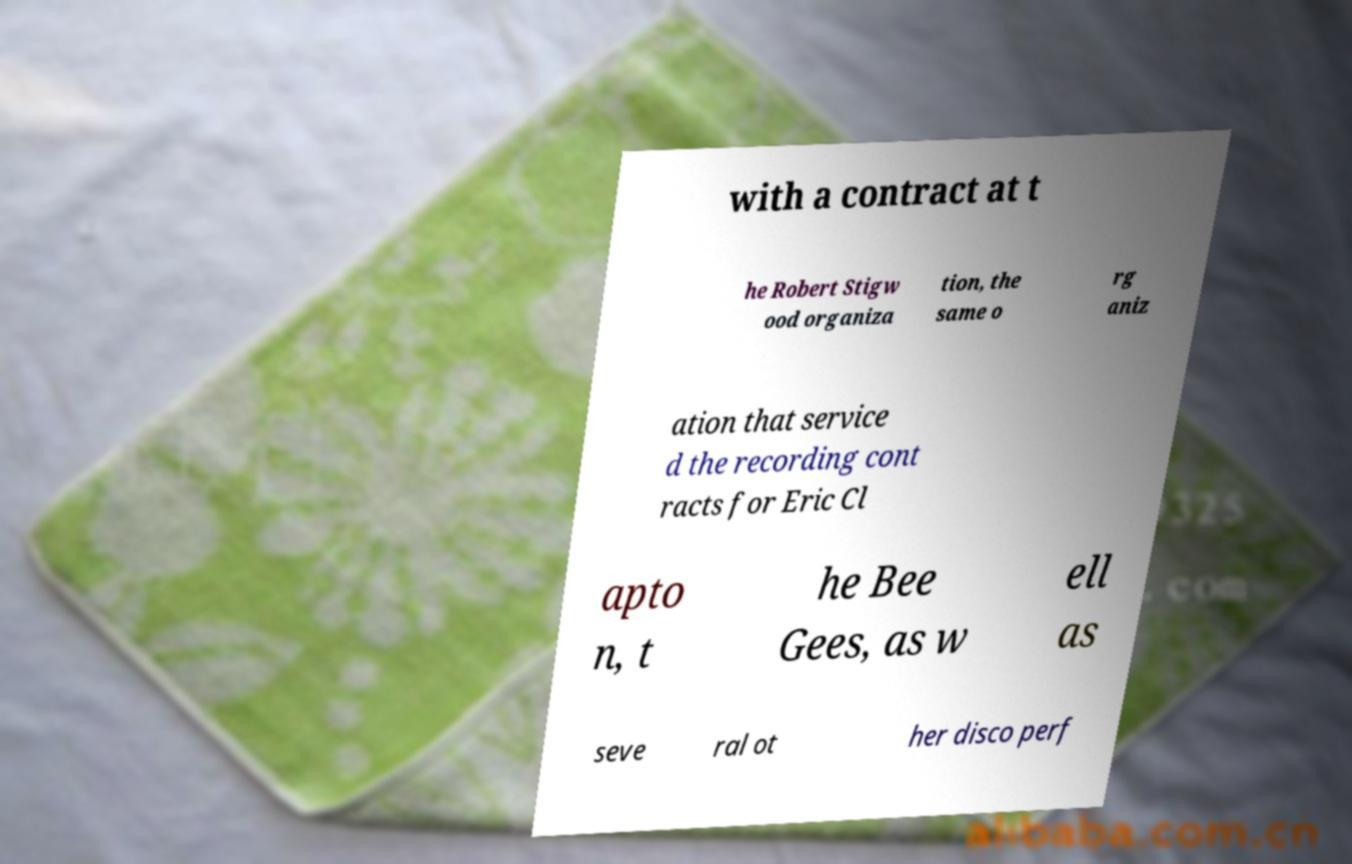Please identify and transcribe the text found in this image. with a contract at t he Robert Stigw ood organiza tion, the same o rg aniz ation that service d the recording cont racts for Eric Cl apto n, t he Bee Gees, as w ell as seve ral ot her disco perf 